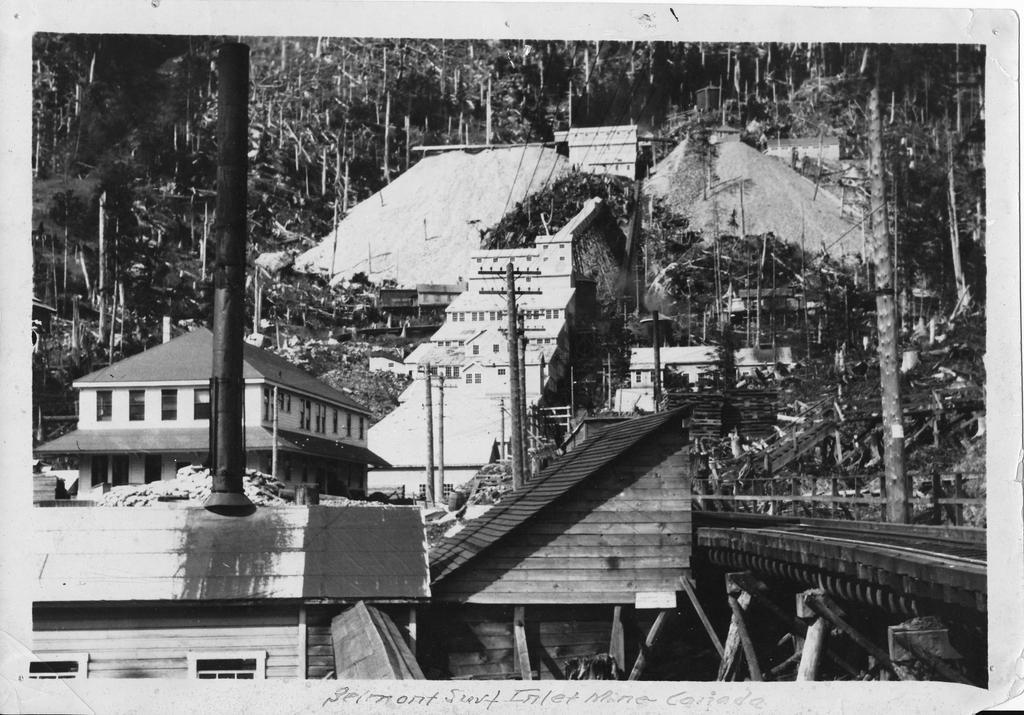Could you give a brief overview of what you see in this image? In this image there is a black and white photo, there are buildings, there are poles, there is a building truncated towards the bottom of the image, there are trees, there are trees truncated towards the top of the image, there are trees truncated left the top of the image, there are trees truncated towards the right of the image, there is an object truncated towards the right of the image, there are objects truncated towards the bottom of the image, there is text on the image. 